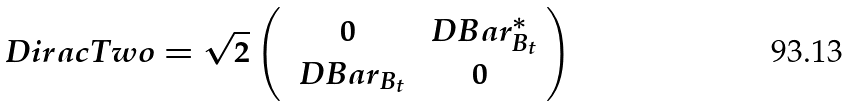Convert formula to latex. <formula><loc_0><loc_0><loc_500><loc_500>\ D i r a c T w o = \sqrt { 2 } \left ( \begin{array} { c c } 0 & \ D B a r _ { B _ { t } } ^ { * } \\ \ D B a r _ { B _ { t } } & 0 \end{array} \right )</formula> 